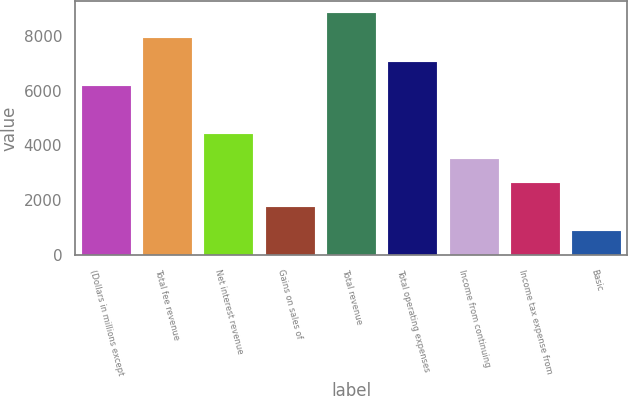Convert chart to OTSL. <chart><loc_0><loc_0><loc_500><loc_500><bar_chart><fcel>(Dollars in millions except<fcel>Total fee revenue<fcel>Net interest revenue<fcel>Gains on sales of<fcel>Total revenue<fcel>Total operating expenses<fcel>Income from continuing<fcel>Income tax expense from<fcel>Basic<nl><fcel>6164.49<fcel>7924.83<fcel>4404.15<fcel>1763.64<fcel>8805<fcel>7044.66<fcel>3523.98<fcel>2643.81<fcel>883.47<nl></chart> 